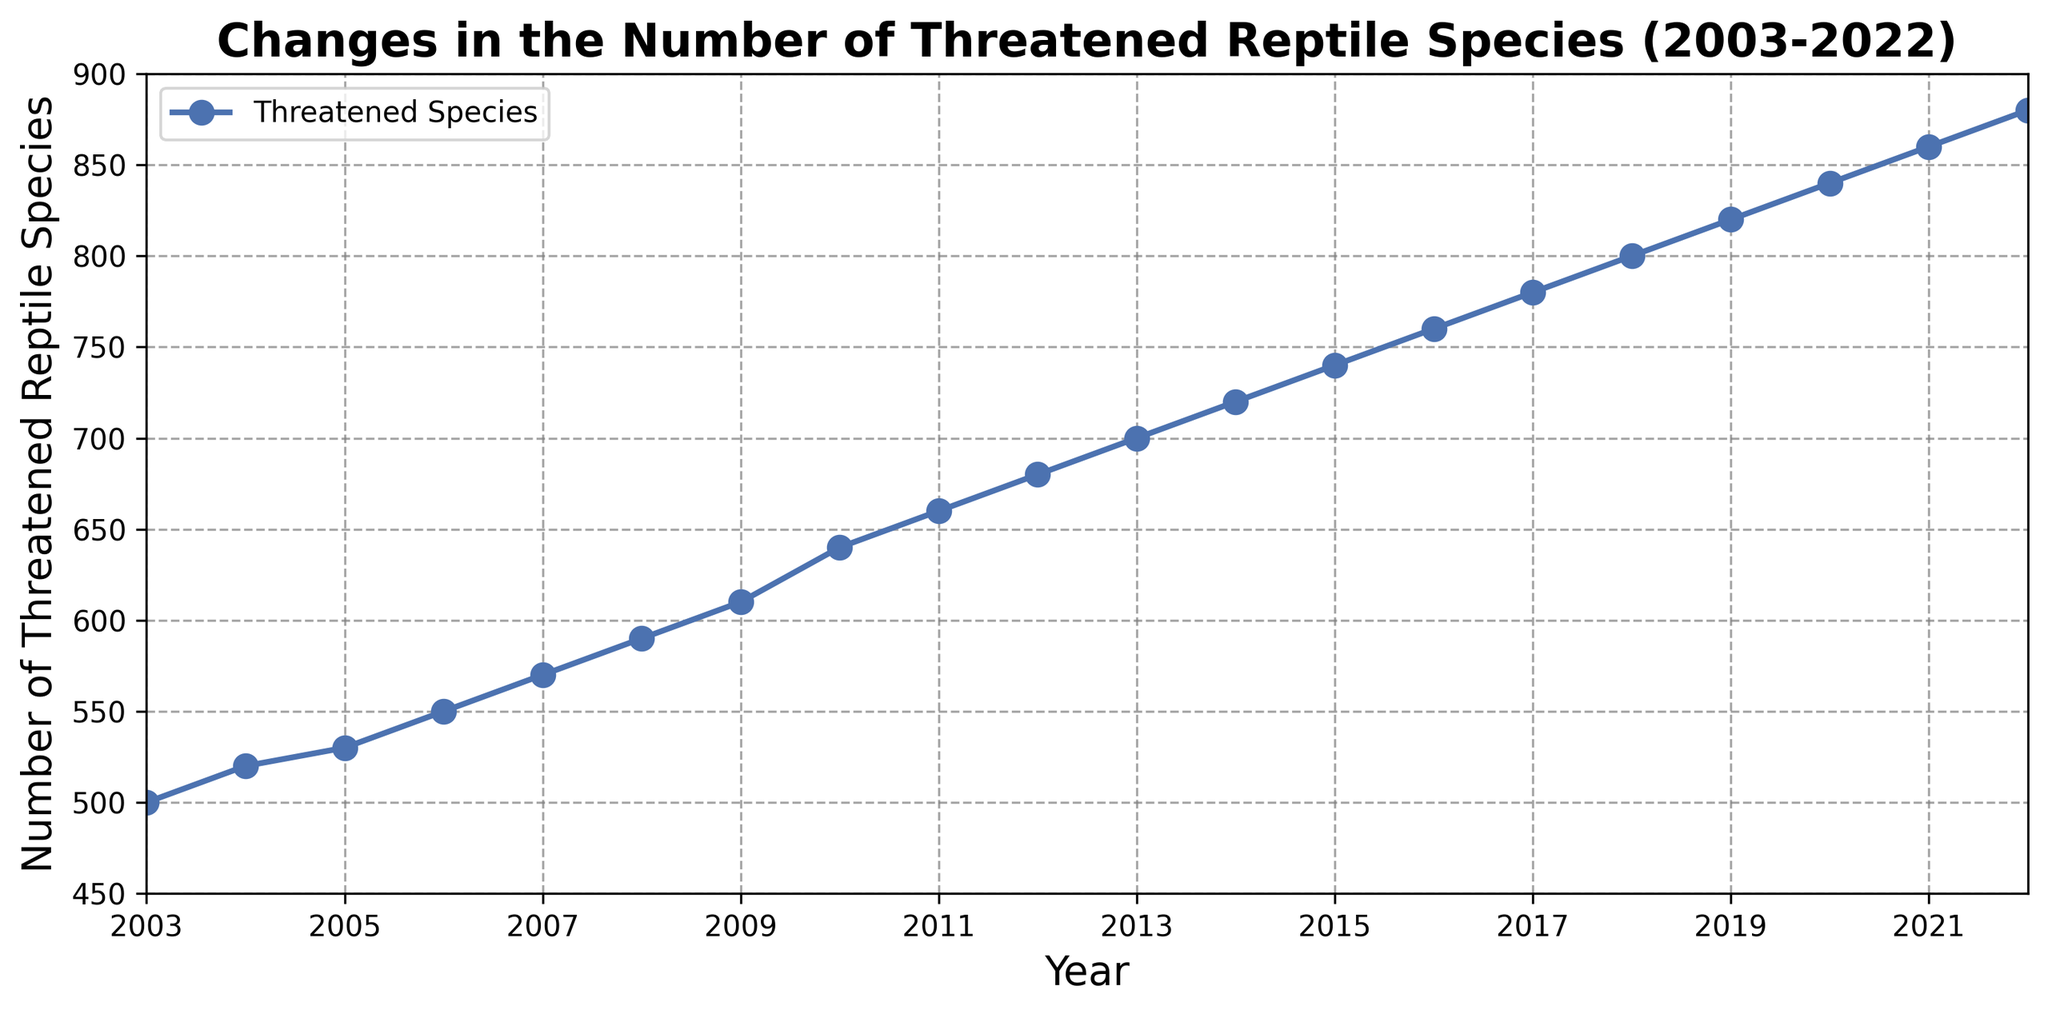What is the trend in the number of threatened reptile species from 2003 to 2022? The overall trend shows a consistent increase in the number of threatened reptile species each year. This is evident as the line plot rises steadily from 500 species in 2003 to 880 species in 2022.
Answer: Increasing In which year did the number of threatened reptile species first reach 800? To find when the number first reached 800, look for the closest data point above 800. In 2018, the number of threatened reptile species is exactly 800.
Answer: 2018 How many more threatened reptile species were there in 2022 compared to 2003? To determine this, subtract the 2003 value from the 2022 value: 880 (2022) - 500 (2003) = 380.
Answer: 380 Which year saw the largest single-year increase in the number of threatened reptile species? Calculate the yearly differences and identify the largest one. The biggest leap occurred between 2009 and 2010, where the species count increased by 30: 640 (2010) - 610 (2009) = 30.
Answer: 2010 How many threatened reptile species were added from 2007 to 2017? By subtracting the number in 2007 from the number in 2017: 780 (2017) - 570 (2007) = 210.
Answer: 210 What is the average number of threatened reptile species from 2003 to 2022? Add up all the yearly values and divide by 20 (number of years): (500 + 520 + 530 + 550 + 570 + 590 + 610 + 640 + 660 + 680 + 700 + 720 + 740 + 760 + 780 + 800 + 820 + 840 + 860 + 880) / 20 = 700.
Answer: 700 What was the least amount of threatened reptile species observed in any given year within this period? By looking at the starting point of the line chart, the number of threatened species begins at 500 in 2003. This is the lowest value in the chart.
Answer: 500 Between which years did the number of threatened reptile species increase by 50? Identify intervals where the increase is exactly 50. Between 2005 and 2007, it rises from 530 to 570 (530, 550, 570).
Answer: 2005 and 2007 Is there any year when the number of threatened reptile species did not increase compared to the previous year? Every year from 2003 to 2022 shows a positive increase in this plot, meaning there is no year with no increase indicated.
Answer: No 